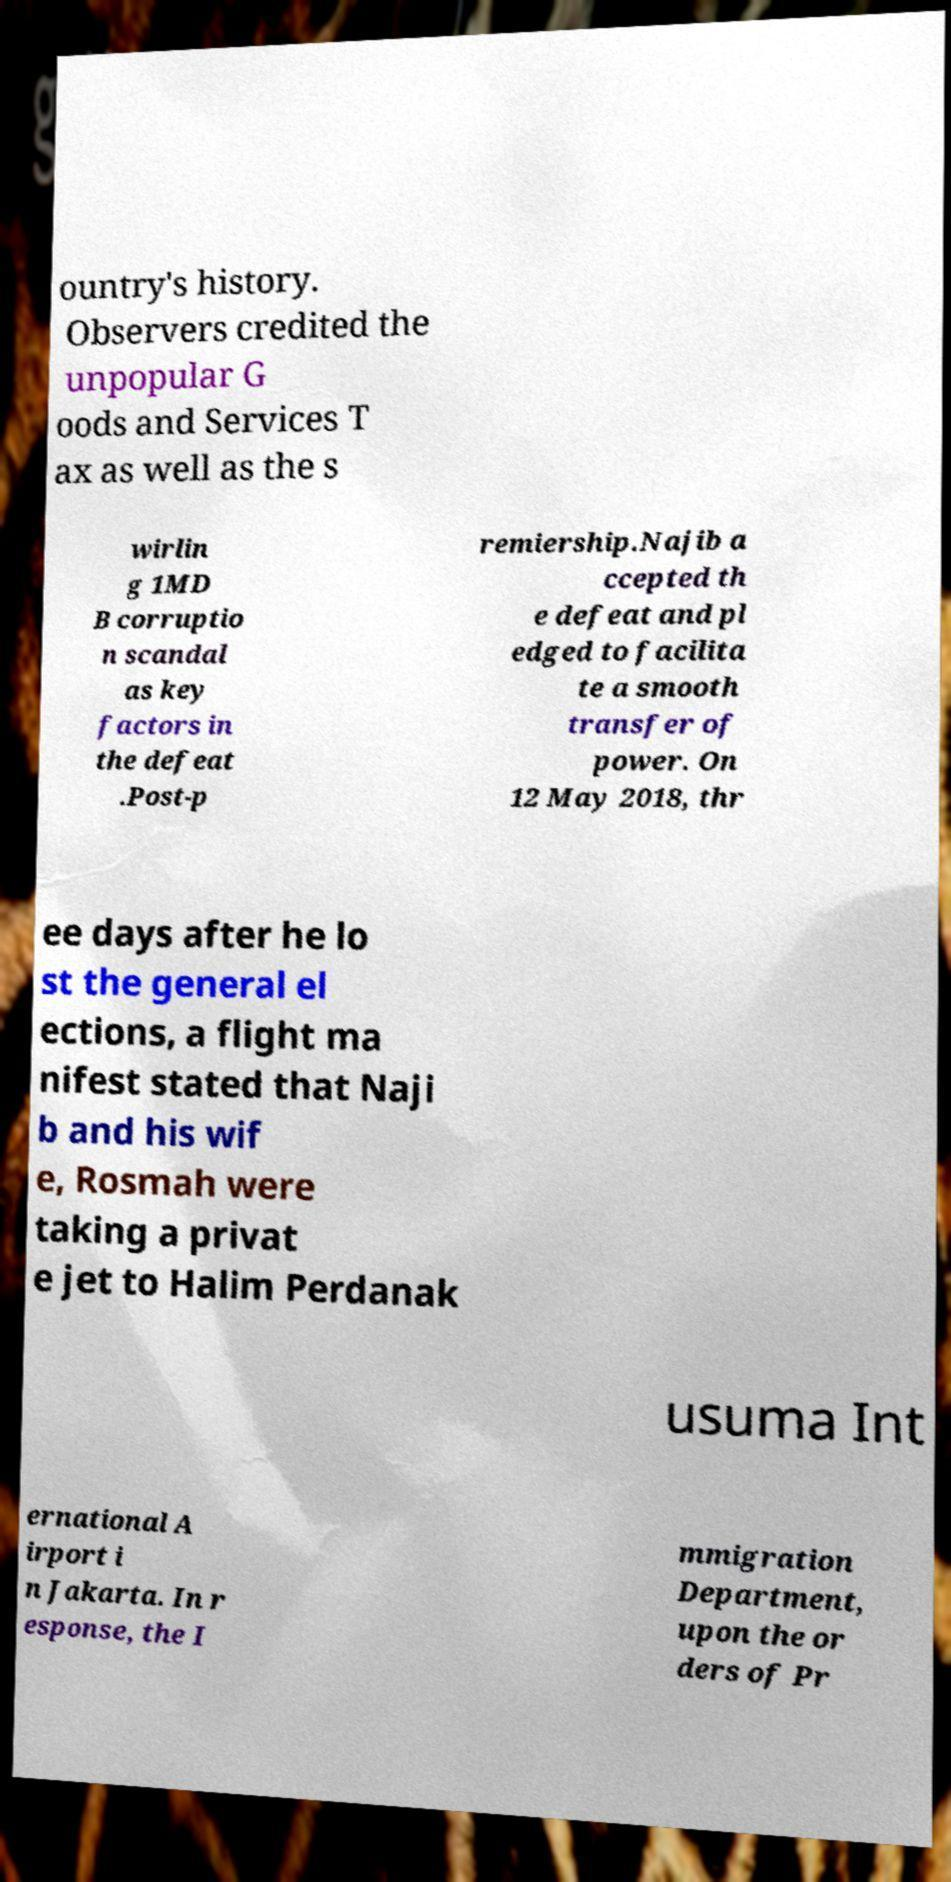Could you extract and type out the text from this image? ountry's history. Observers credited the unpopular G oods and Services T ax as well as the s wirlin g 1MD B corruptio n scandal as key factors in the defeat .Post-p remiership.Najib a ccepted th e defeat and pl edged to facilita te a smooth transfer of power. On 12 May 2018, thr ee days after he lo st the general el ections, a flight ma nifest stated that Naji b and his wif e, Rosmah were taking a privat e jet to Halim Perdanak usuma Int ernational A irport i n Jakarta. In r esponse, the I mmigration Department, upon the or ders of Pr 